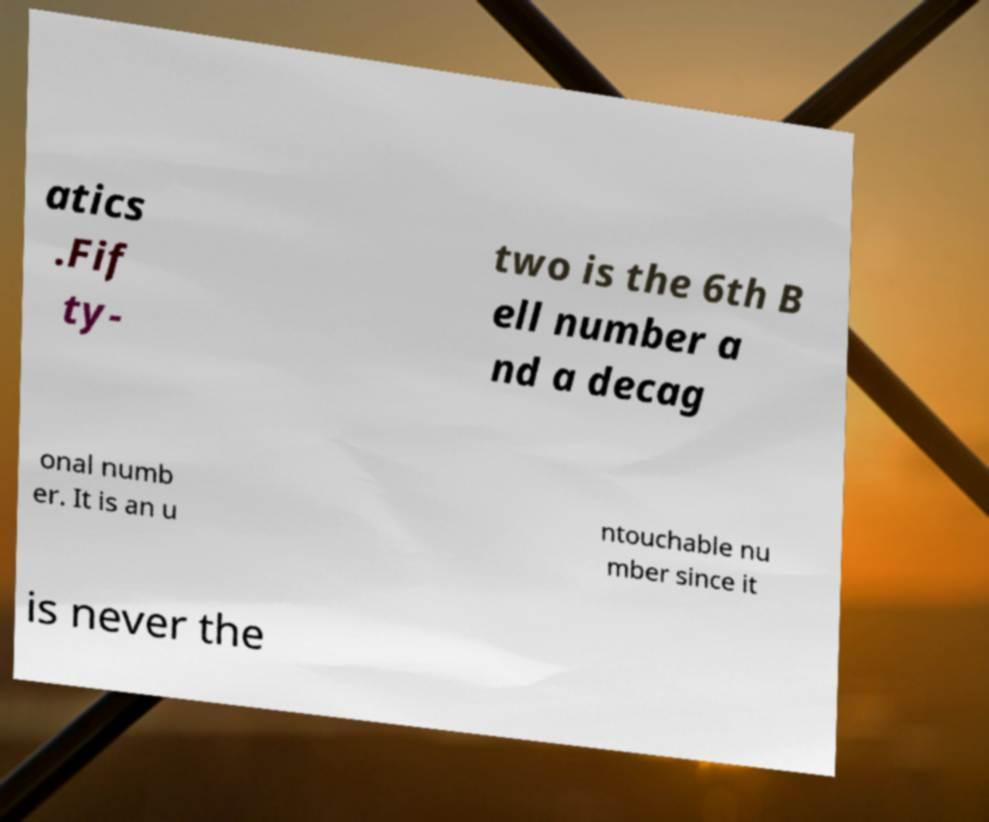Can you accurately transcribe the text from the provided image for me? atics .Fif ty- two is the 6th B ell number a nd a decag onal numb er. It is an u ntouchable nu mber since it is never the 